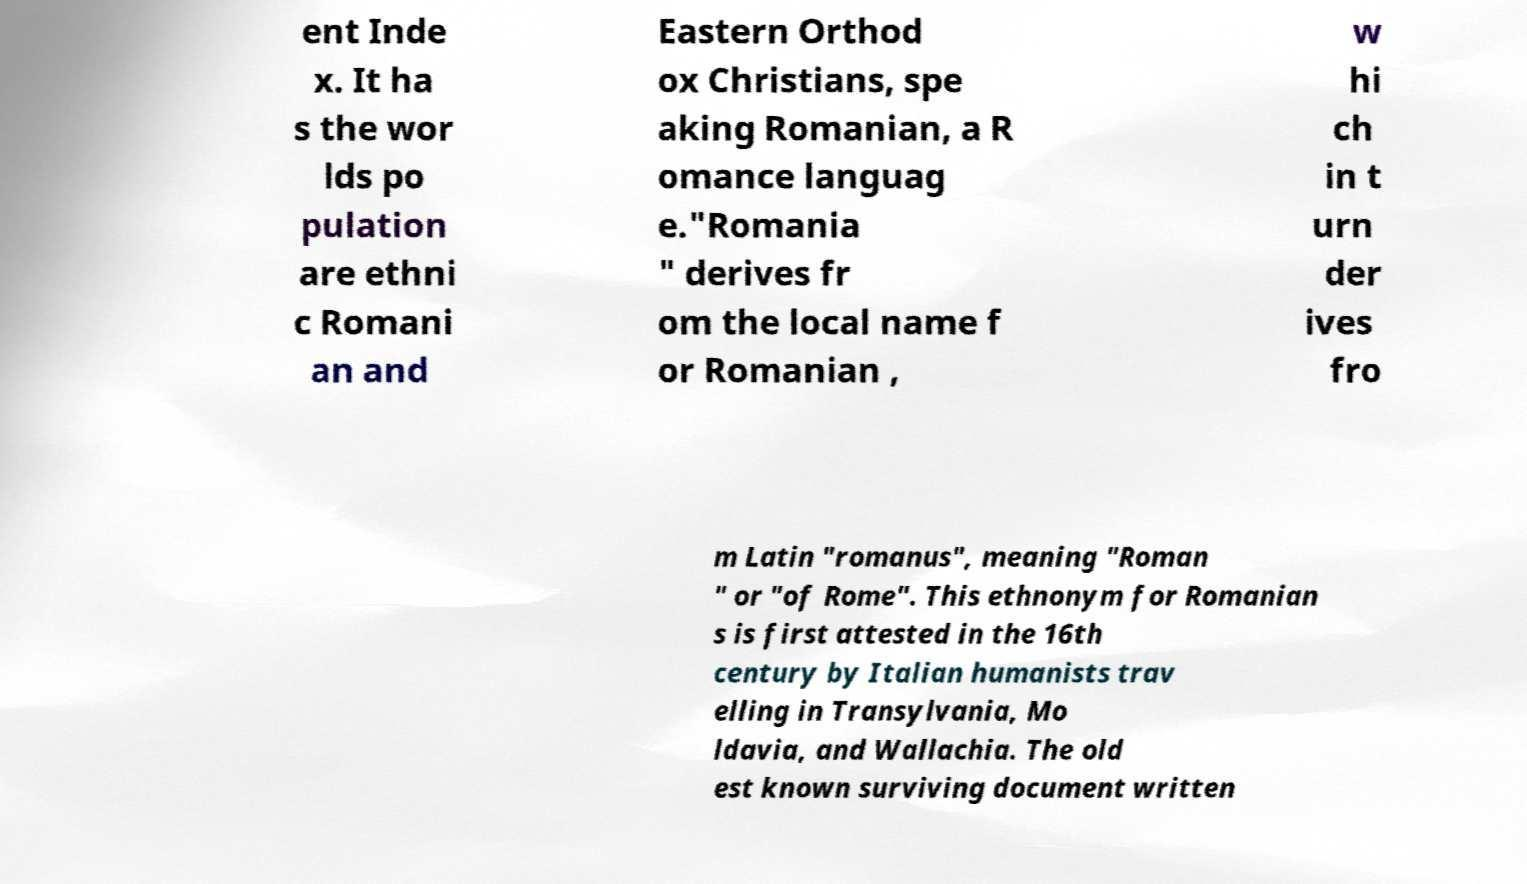Can you accurately transcribe the text from the provided image for me? ent Inde x. It ha s the wor lds po pulation are ethni c Romani an and Eastern Orthod ox Christians, spe aking Romanian, a R omance languag e."Romania " derives fr om the local name f or Romanian , w hi ch in t urn der ives fro m Latin "romanus", meaning "Roman " or "of Rome". This ethnonym for Romanian s is first attested in the 16th century by Italian humanists trav elling in Transylvania, Mo ldavia, and Wallachia. The old est known surviving document written 